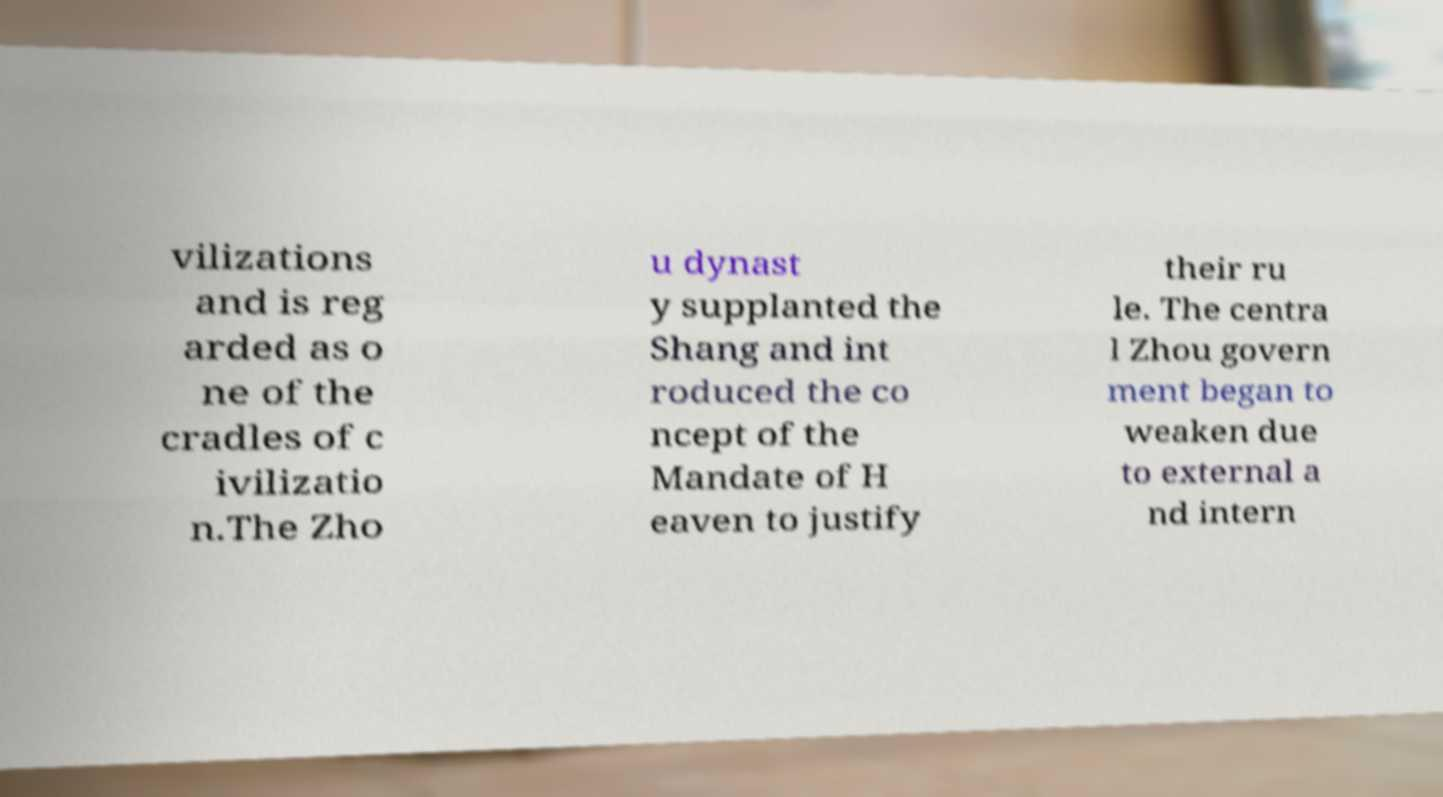What messages or text are displayed in this image? I need them in a readable, typed format. vilizations and is reg arded as o ne of the cradles of c ivilizatio n.The Zho u dynast y supplanted the Shang and int roduced the co ncept of the Mandate of H eaven to justify their ru le. The centra l Zhou govern ment began to weaken due to external a nd intern 